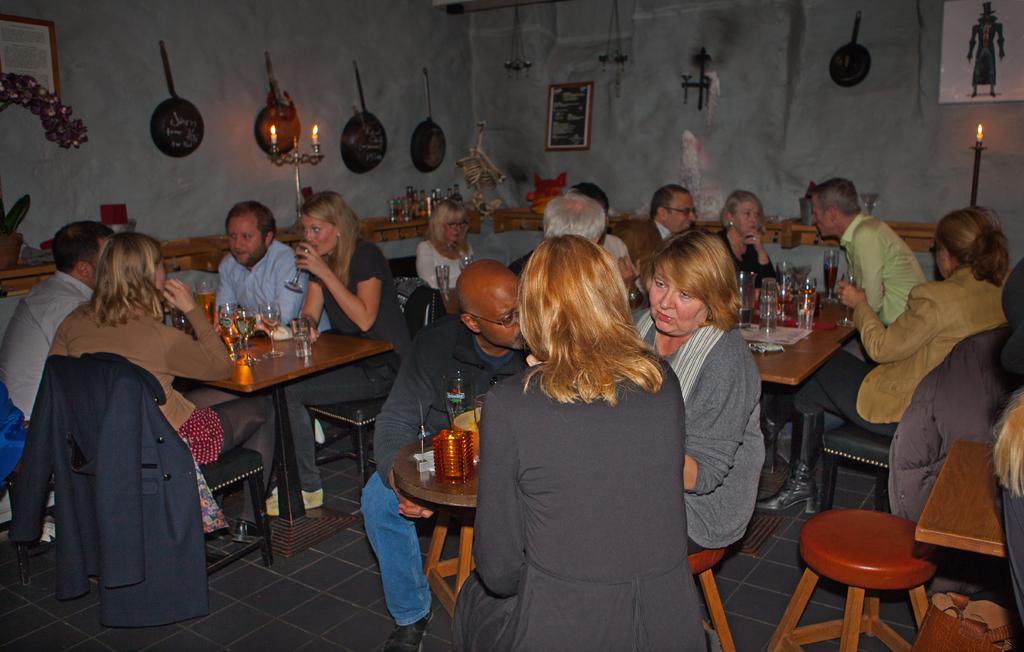In one or two sentences, can you explain what this image depicts? This image is clicked in a room. There are so many tables on that tables there are glasses ,bottles, candles, on the right side there is a candle ,on the left side also ,there is a candle ,there are pans hanging over walls ,there is a photo frame in the middle ,there are stools ,chairs. People are sitting on stools and chairs around that tables. 